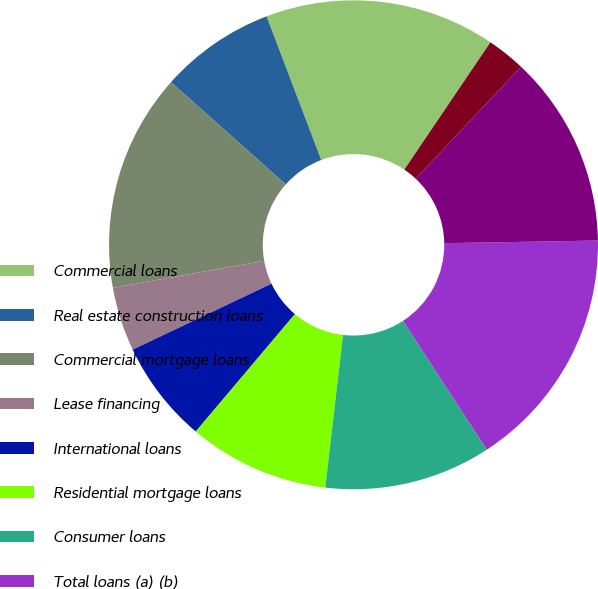<chart> <loc_0><loc_0><loc_500><loc_500><pie_chart><fcel>Commercial loans<fcel>Real estate construction loans<fcel>Commercial mortgage loans<fcel>Lease financing<fcel>International loans<fcel>Residential mortgage loans<fcel>Consumer loans<fcel>Total loans (a) (b)<fcel>Mortgage-backed securities<fcel>Other investment securities<nl><fcel>15.25%<fcel>7.63%<fcel>14.4%<fcel>4.24%<fcel>6.78%<fcel>9.32%<fcel>11.02%<fcel>16.1%<fcel>12.71%<fcel>2.55%<nl></chart> 